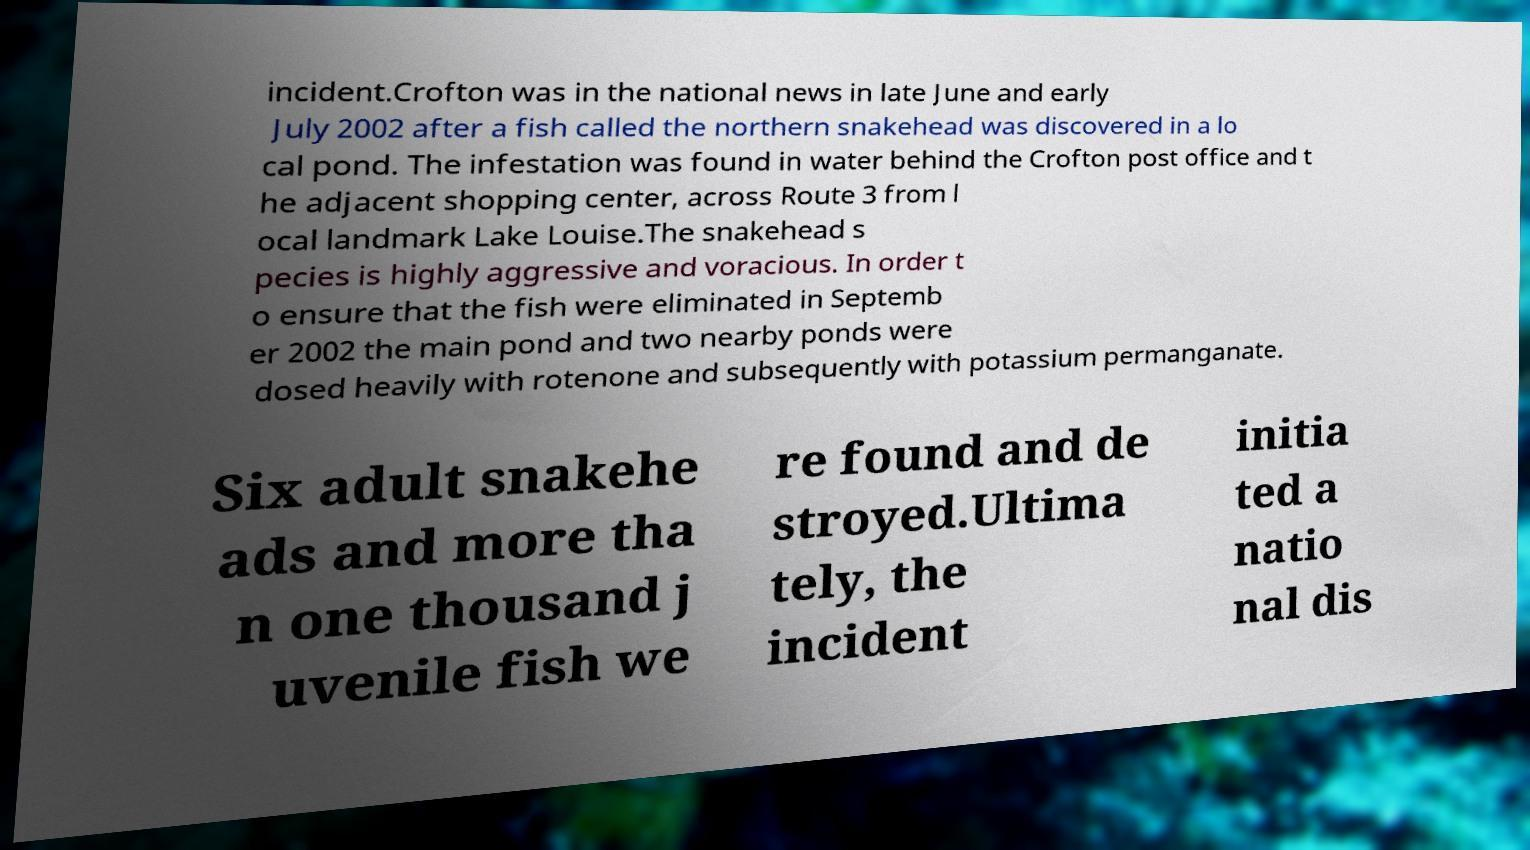Could you assist in decoding the text presented in this image and type it out clearly? incident.Crofton was in the national news in late June and early July 2002 after a fish called the northern snakehead was discovered in a lo cal pond. The infestation was found in water behind the Crofton post office and t he adjacent shopping center, across Route 3 from l ocal landmark Lake Louise.The snakehead s pecies is highly aggressive and voracious. In order t o ensure that the fish were eliminated in Septemb er 2002 the main pond and two nearby ponds were dosed heavily with rotenone and subsequently with potassium permanganate. Six adult snakehe ads and more tha n one thousand j uvenile fish we re found and de stroyed.Ultima tely, the incident initia ted a natio nal dis 